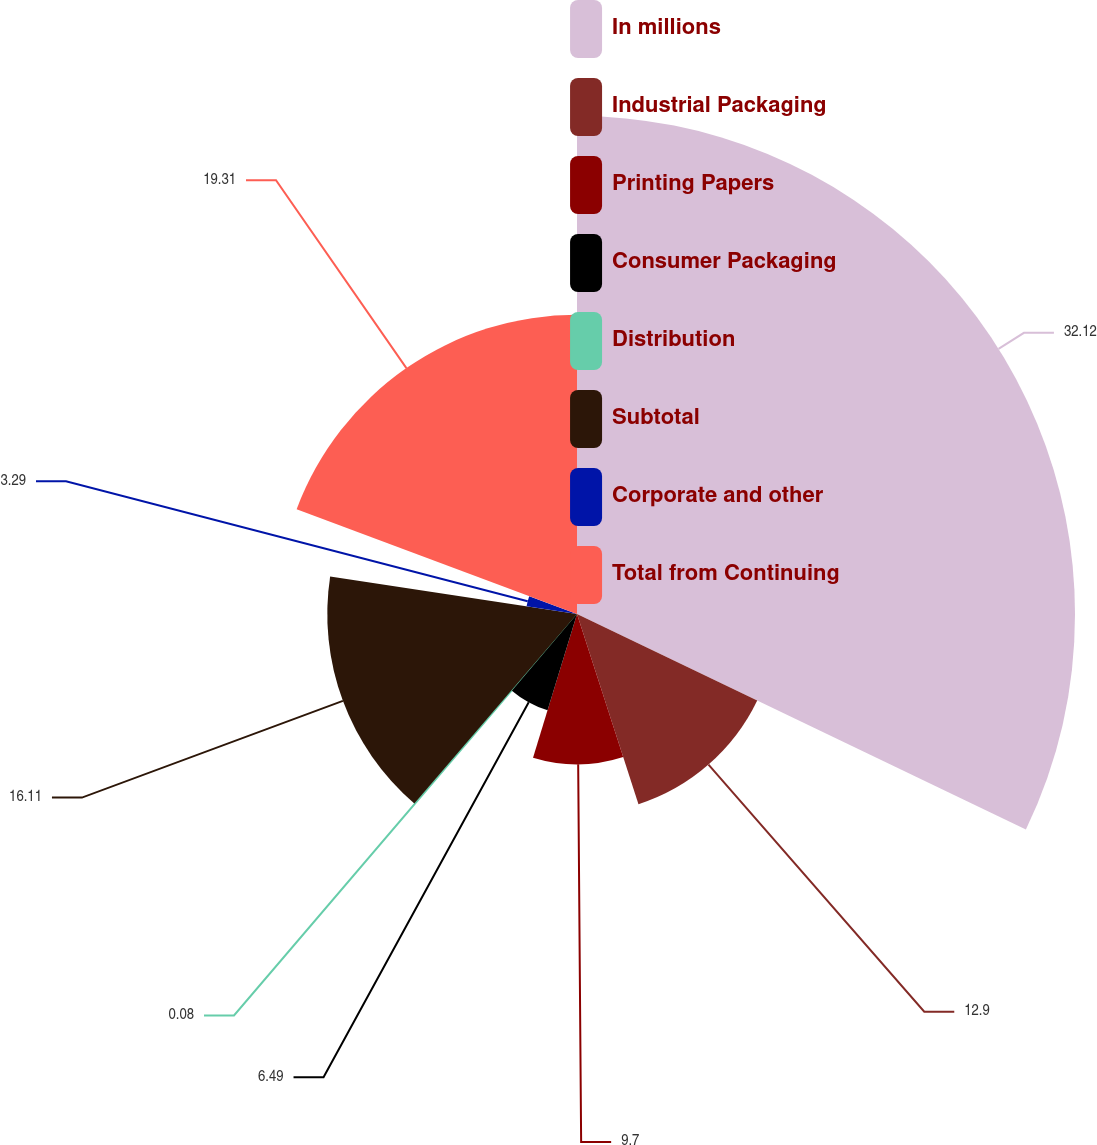Convert chart. <chart><loc_0><loc_0><loc_500><loc_500><pie_chart><fcel>In millions<fcel>Industrial Packaging<fcel>Printing Papers<fcel>Consumer Packaging<fcel>Distribution<fcel>Subtotal<fcel>Corporate and other<fcel>Total from Continuing<nl><fcel>32.13%<fcel>12.9%<fcel>9.7%<fcel>6.49%<fcel>0.08%<fcel>16.11%<fcel>3.29%<fcel>19.31%<nl></chart> 